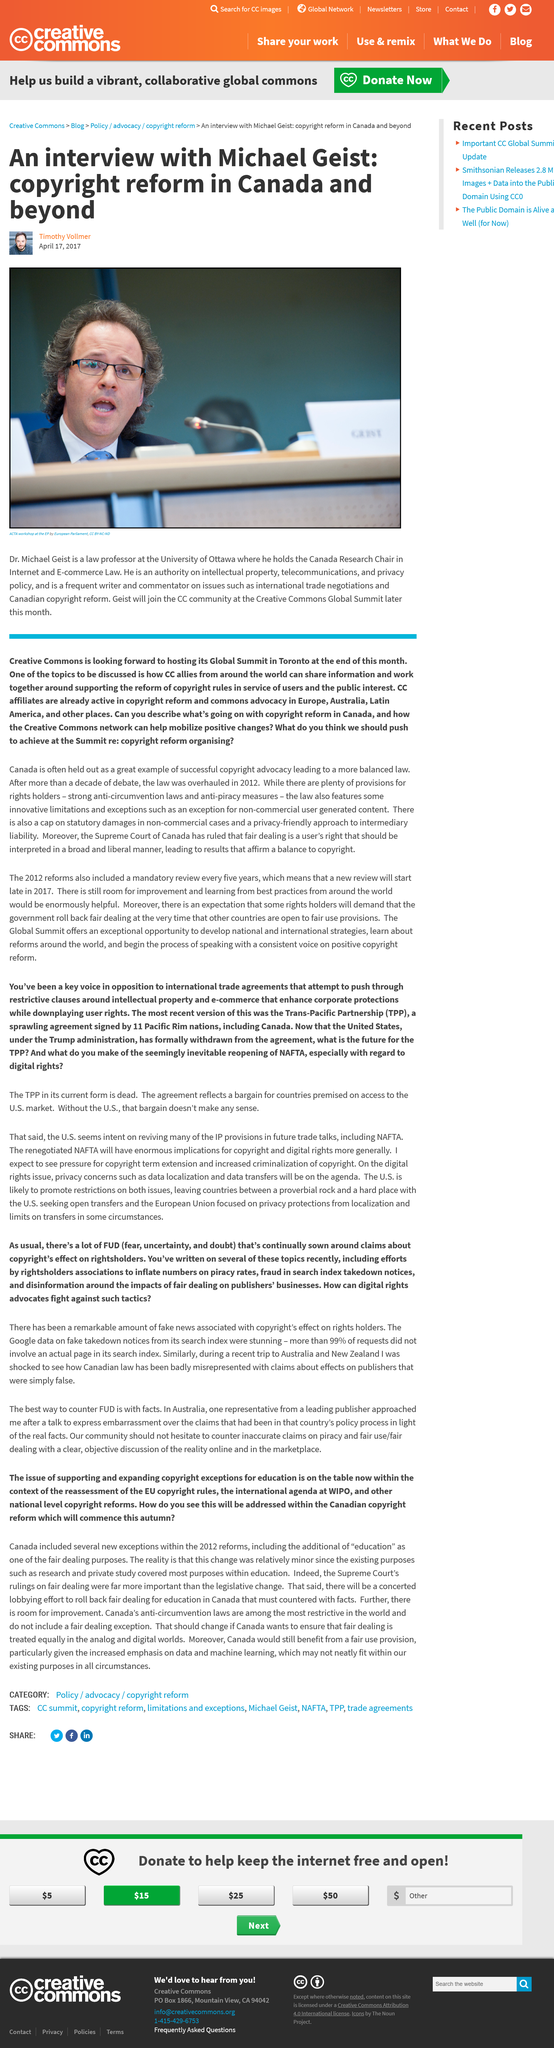Identify some key points in this picture. Dr. Geist is a law professor at the University of Ottawa. Dr. Geist works in Canada, which is a country. Geist will join the CC community in April. 